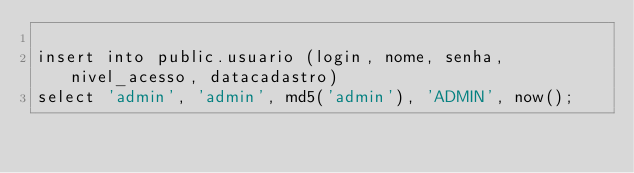<code> <loc_0><loc_0><loc_500><loc_500><_SQL_>
insert into public.usuario (login, nome, senha, nivel_acesso, datacadastro)
select 'admin', 'admin', md5('admin'), 'ADMIN', now();
</code> 